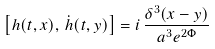Convert formula to latex. <formula><loc_0><loc_0><loc_500><loc_500>\left [ h ( t , x ) , \, \dot { h } ( t , y ) \right ] = i \, \frac { \delta ^ { 3 } ( x - y ) } { a ^ { 3 } e ^ { 2 \Phi } }</formula> 